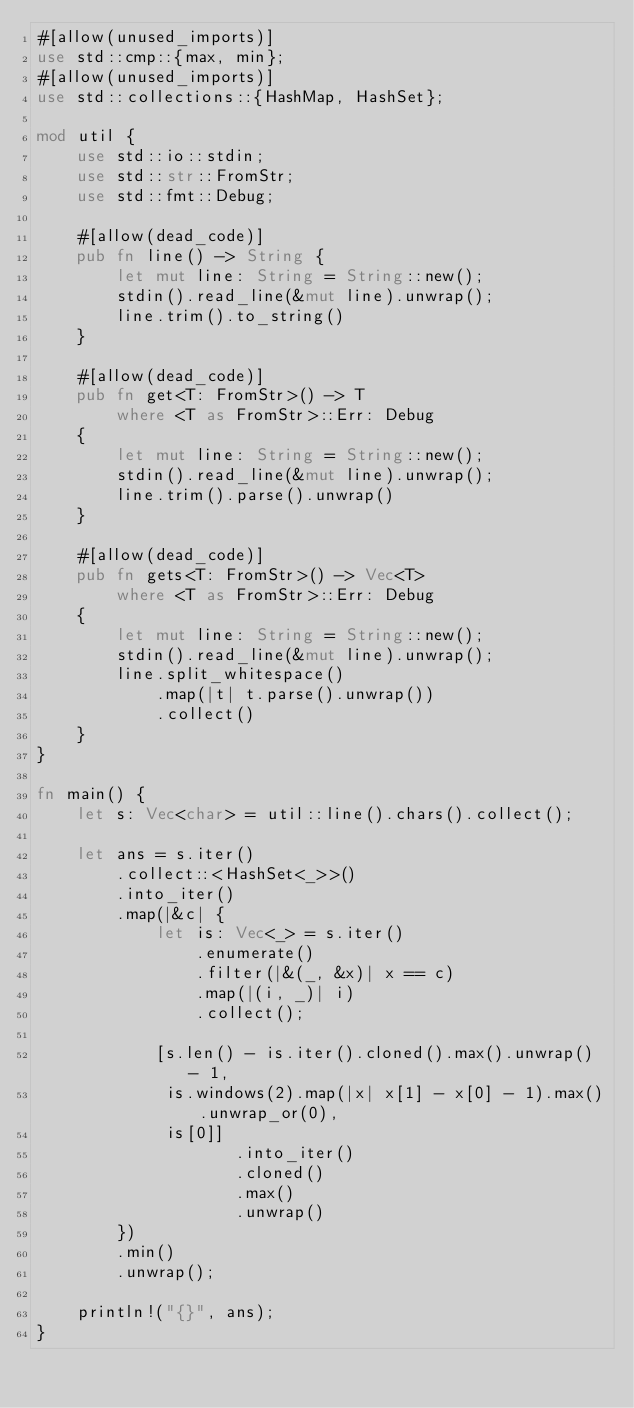<code> <loc_0><loc_0><loc_500><loc_500><_Rust_>#[allow(unused_imports)]
use std::cmp::{max, min};
#[allow(unused_imports)]
use std::collections::{HashMap, HashSet};

mod util {
    use std::io::stdin;
    use std::str::FromStr;
    use std::fmt::Debug;

    #[allow(dead_code)]
    pub fn line() -> String {
        let mut line: String = String::new();
        stdin().read_line(&mut line).unwrap();
        line.trim().to_string()
    }

    #[allow(dead_code)]
    pub fn get<T: FromStr>() -> T
        where <T as FromStr>::Err: Debug
    {
        let mut line: String = String::new();
        stdin().read_line(&mut line).unwrap();
        line.trim().parse().unwrap()
    }

    #[allow(dead_code)]
    pub fn gets<T: FromStr>() -> Vec<T>
        where <T as FromStr>::Err: Debug
    {
        let mut line: String = String::new();
        stdin().read_line(&mut line).unwrap();
        line.split_whitespace()
            .map(|t| t.parse().unwrap())
            .collect()
    }
}

fn main() {
    let s: Vec<char> = util::line().chars().collect();

    let ans = s.iter()
        .collect::<HashSet<_>>()
        .into_iter()
        .map(|&c| {
            let is: Vec<_> = s.iter()
                .enumerate()
                .filter(|&(_, &x)| x == c)
                .map(|(i, _)| i)
                .collect();

            [s.len() - is.iter().cloned().max().unwrap() - 1,
             is.windows(2).map(|x| x[1] - x[0] - 1).max().unwrap_or(0),
             is[0]]
                    .into_iter()
                    .cloned()
                    .max()
                    .unwrap()
        })
        .min()
        .unwrap();

    println!("{}", ans);
}
</code> 